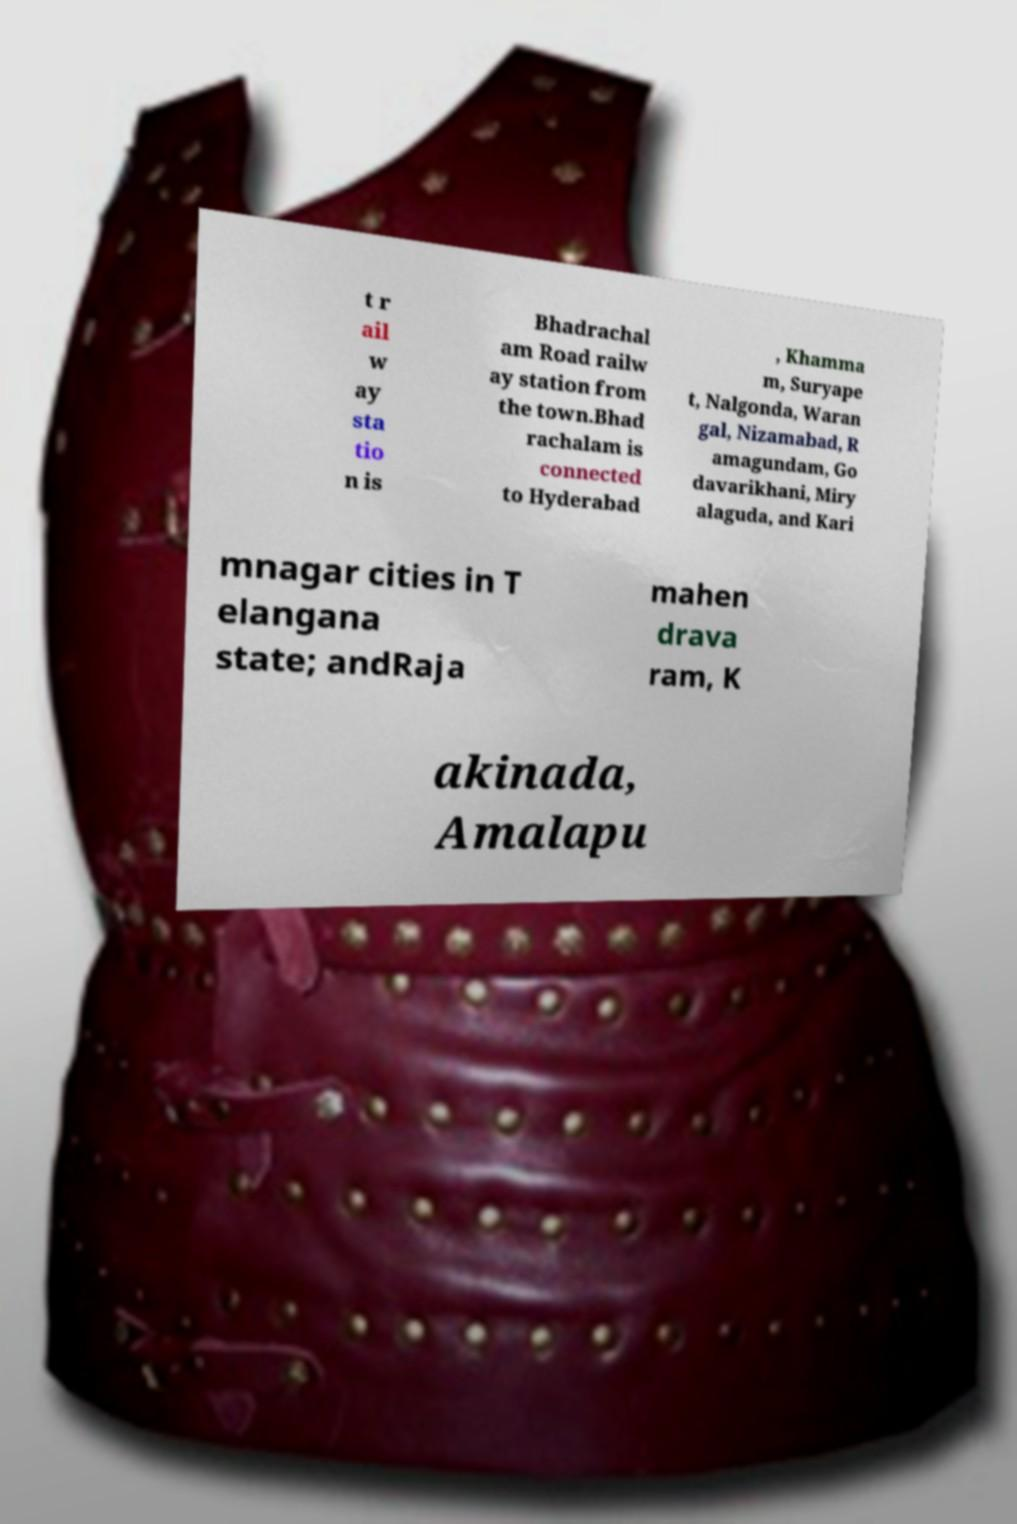What messages or text are displayed in this image? I need them in a readable, typed format. t r ail w ay sta tio n is Bhadrachal am Road railw ay station from the town.Bhad rachalam is connected to Hyderabad , Khamma m, Suryape t, Nalgonda, Waran gal, Nizamabad, R amagundam, Go davarikhani, Miry alaguda, and Kari mnagar cities in T elangana state; andRaja mahen drava ram, K akinada, Amalapu 